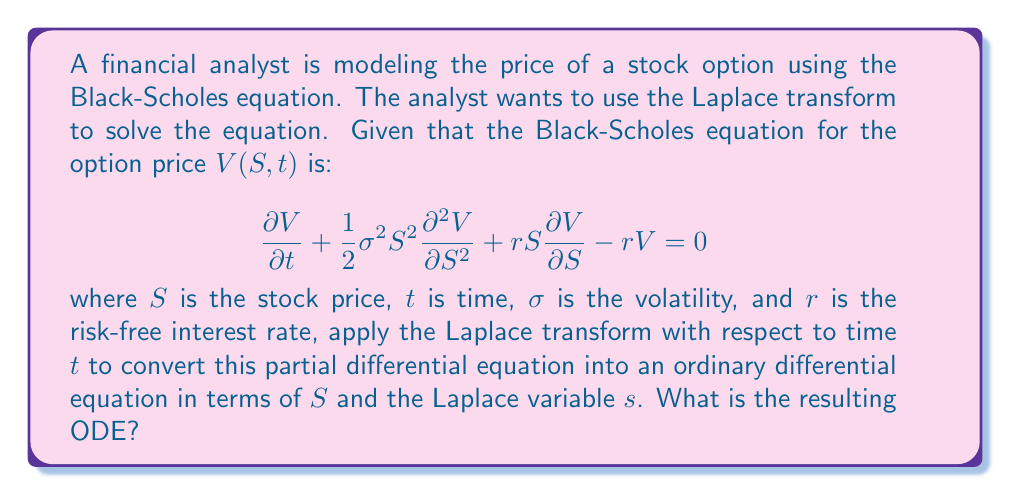What is the answer to this math problem? To solve this problem, we need to apply the Laplace transform to the Black-Scholes equation with respect to time $t$. Let's denote the Laplace transform of $V(S,t)$ as $\bar{V}(S,s)$.

1) First, let's apply the Laplace transform to each term of the equation:

   a) $\mathcal{L}\left\{\frac{\partial V}{\partial t}\right\} = s\bar{V}(S,s) - V(S,0)$
   
   b) $\mathcal{L}\left\{\frac{\partial^2 V}{\partial S^2}\right\} = \frac{\partial^2 \bar{V}}{\partial S^2}$
   
   c) $\mathcal{L}\left\{\frac{\partial V}{\partial S}\right\} = \frac{\partial \bar{V}}{\partial S}$
   
   d) $\mathcal{L}\{V\} = \bar{V}(S,s)$

2) Now, let's substitute these into the original equation:

   $$s\bar{V}(S,s) - V(S,0) + \frac{1}{2}\sigma^2S^2\frac{\partial^2 \bar{V}}{\partial S^2} + rS\frac{\partial \bar{V}}{\partial S} - r\bar{V}(S,s) = 0$$

3) Rearrange the terms:

   $$\frac{1}{2}\sigma^2S^2\frac{\partial^2 \bar{V}}{\partial S^2} + rS\frac{\partial \bar{V}}{\partial S} - (r+s)\bar{V}(S,s) = -V(S,0)$$

4) This is now an ordinary differential equation in terms of $S$ and the Laplace variable $s$. The term $V(S,0)$ represents the initial condition of the option price at $t=0$.
Answer: The resulting ODE after applying the Laplace transform to the Black-Scholes equation is:

$$\frac{1}{2}\sigma^2S^2\frac{\partial^2 \bar{V}}{\partial S^2} + rS\frac{\partial \bar{V}}{\partial S} - (r+s)\bar{V}(S,s) = -V(S,0)$$

where $\bar{V}(S,s)$ is the Laplace transform of $V(S,t)$ with respect to time $t$. 